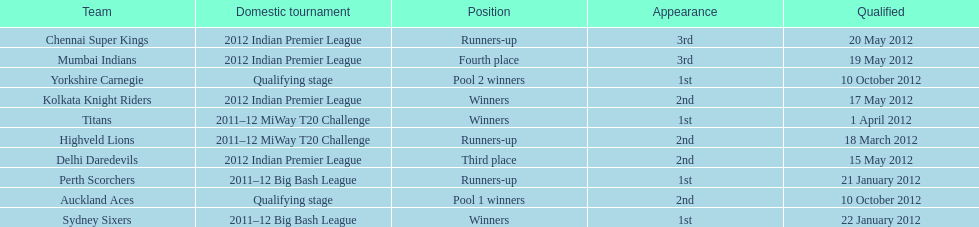Which game came in first in the 2012 indian premier league? Kolkata Knight Riders. 